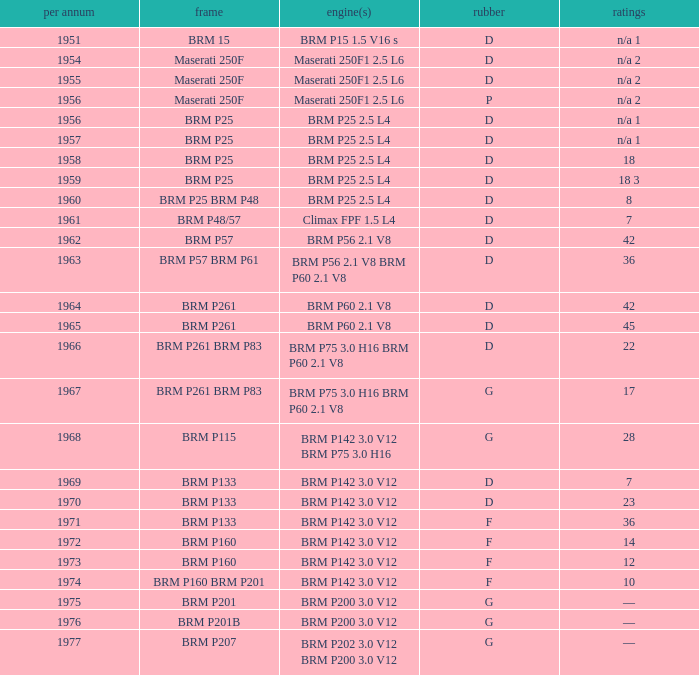Name the sum of year for engine of brm p202 3.0 v12 brm p200 3.0 v12 1977.0. 